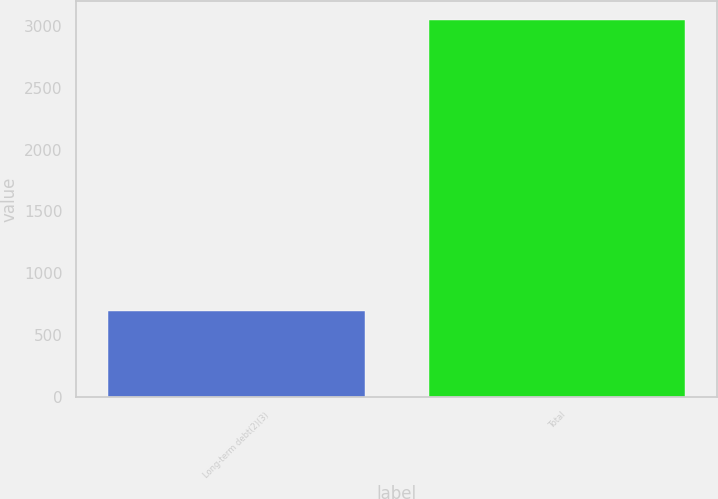Convert chart. <chart><loc_0><loc_0><loc_500><loc_500><bar_chart><fcel>Long-term debt(2)(3)<fcel>Total<nl><fcel>700<fcel>3044<nl></chart> 